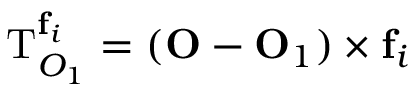Convert formula to latex. <formula><loc_0><loc_0><loc_500><loc_500>T _ { O _ { 1 } } ^ { f _ { i } } = ( O - O _ { 1 } ) \times f _ { i }</formula> 